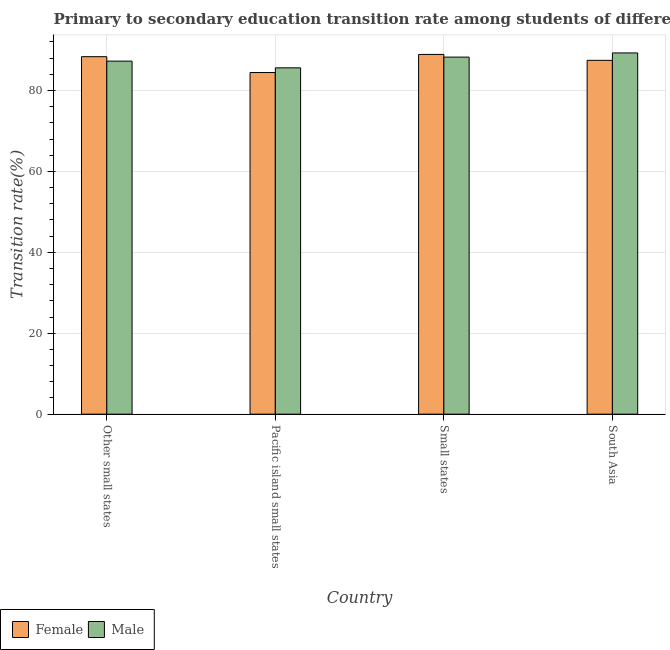How many different coloured bars are there?
Your answer should be very brief. 2. Are the number of bars per tick equal to the number of legend labels?
Keep it short and to the point. Yes. How many bars are there on the 1st tick from the left?
Provide a short and direct response. 2. How many bars are there on the 4th tick from the right?
Give a very brief answer. 2. What is the label of the 3rd group of bars from the left?
Keep it short and to the point. Small states. What is the transition rate among female students in South Asia?
Offer a terse response. 87.46. Across all countries, what is the maximum transition rate among male students?
Your response must be concise. 89.29. Across all countries, what is the minimum transition rate among female students?
Ensure brevity in your answer.  84.44. In which country was the transition rate among male students minimum?
Your answer should be very brief. Pacific island small states. What is the total transition rate among male students in the graph?
Give a very brief answer. 350.4. What is the difference between the transition rate among male students in Other small states and that in Small states?
Provide a short and direct response. -1. What is the difference between the transition rate among male students in Small states and the transition rate among female students in Other small states?
Offer a terse response. -0.11. What is the average transition rate among male students per country?
Your answer should be compact. 87.6. What is the difference between the transition rate among male students and transition rate among female students in Other small states?
Make the answer very short. -1.1. What is the ratio of the transition rate among male students in Pacific island small states to that in Small states?
Your answer should be compact. 0.97. Is the transition rate among male students in Other small states less than that in Pacific island small states?
Ensure brevity in your answer.  No. Is the difference between the transition rate among female students in Pacific island small states and Small states greater than the difference between the transition rate among male students in Pacific island small states and Small states?
Give a very brief answer. No. What is the difference between the highest and the second highest transition rate among female students?
Ensure brevity in your answer.  0.55. What is the difference between the highest and the lowest transition rate among female students?
Ensure brevity in your answer.  4.47. What does the 1st bar from the left in Other small states represents?
Keep it short and to the point. Female. Are all the bars in the graph horizontal?
Your response must be concise. No. How many countries are there in the graph?
Ensure brevity in your answer.  4. Are the values on the major ticks of Y-axis written in scientific E-notation?
Your answer should be compact. No. Does the graph contain grids?
Offer a very short reply. Yes. How many legend labels are there?
Offer a terse response. 2. What is the title of the graph?
Offer a terse response. Primary to secondary education transition rate among students of different countries. Does "Public funds" appear as one of the legend labels in the graph?
Ensure brevity in your answer.  No. What is the label or title of the X-axis?
Provide a succinct answer. Country. What is the label or title of the Y-axis?
Offer a very short reply. Transition rate(%). What is the Transition rate(%) in Female in Other small states?
Your response must be concise. 88.36. What is the Transition rate(%) in Male in Other small states?
Give a very brief answer. 87.26. What is the Transition rate(%) of Female in Pacific island small states?
Your answer should be compact. 84.44. What is the Transition rate(%) in Male in Pacific island small states?
Offer a very short reply. 85.6. What is the Transition rate(%) in Female in Small states?
Keep it short and to the point. 88.91. What is the Transition rate(%) in Male in Small states?
Offer a very short reply. 88.25. What is the Transition rate(%) in Female in South Asia?
Offer a very short reply. 87.46. What is the Transition rate(%) of Male in South Asia?
Your answer should be compact. 89.29. Across all countries, what is the maximum Transition rate(%) in Female?
Offer a terse response. 88.91. Across all countries, what is the maximum Transition rate(%) in Male?
Offer a very short reply. 89.29. Across all countries, what is the minimum Transition rate(%) of Female?
Make the answer very short. 84.44. Across all countries, what is the minimum Transition rate(%) in Male?
Your answer should be very brief. 85.6. What is the total Transition rate(%) of Female in the graph?
Provide a succinct answer. 349.18. What is the total Transition rate(%) in Male in the graph?
Offer a terse response. 350.4. What is the difference between the Transition rate(%) in Female in Other small states and that in Pacific island small states?
Provide a short and direct response. 3.92. What is the difference between the Transition rate(%) in Male in Other small states and that in Pacific island small states?
Give a very brief answer. 1.66. What is the difference between the Transition rate(%) in Female in Other small states and that in Small states?
Your response must be concise. -0.55. What is the difference between the Transition rate(%) in Male in Other small states and that in Small states?
Ensure brevity in your answer.  -1. What is the difference between the Transition rate(%) of Female in Other small states and that in South Asia?
Your answer should be compact. 0.9. What is the difference between the Transition rate(%) in Male in Other small states and that in South Asia?
Give a very brief answer. -2.03. What is the difference between the Transition rate(%) of Female in Pacific island small states and that in Small states?
Make the answer very short. -4.47. What is the difference between the Transition rate(%) of Male in Pacific island small states and that in Small states?
Provide a short and direct response. -2.65. What is the difference between the Transition rate(%) of Female in Pacific island small states and that in South Asia?
Your answer should be very brief. -3.01. What is the difference between the Transition rate(%) in Male in Pacific island small states and that in South Asia?
Keep it short and to the point. -3.68. What is the difference between the Transition rate(%) in Female in Small states and that in South Asia?
Your answer should be compact. 1.46. What is the difference between the Transition rate(%) of Male in Small states and that in South Asia?
Your response must be concise. -1.03. What is the difference between the Transition rate(%) in Female in Other small states and the Transition rate(%) in Male in Pacific island small states?
Offer a very short reply. 2.76. What is the difference between the Transition rate(%) of Female in Other small states and the Transition rate(%) of Male in Small states?
Provide a short and direct response. 0.11. What is the difference between the Transition rate(%) of Female in Other small states and the Transition rate(%) of Male in South Asia?
Make the answer very short. -0.92. What is the difference between the Transition rate(%) of Female in Pacific island small states and the Transition rate(%) of Male in Small states?
Offer a terse response. -3.81. What is the difference between the Transition rate(%) in Female in Pacific island small states and the Transition rate(%) in Male in South Asia?
Give a very brief answer. -4.84. What is the difference between the Transition rate(%) of Female in Small states and the Transition rate(%) of Male in South Asia?
Your response must be concise. -0.37. What is the average Transition rate(%) of Female per country?
Make the answer very short. 87.29. What is the average Transition rate(%) of Male per country?
Your answer should be very brief. 87.6. What is the difference between the Transition rate(%) in Female and Transition rate(%) in Male in Other small states?
Provide a short and direct response. 1.1. What is the difference between the Transition rate(%) in Female and Transition rate(%) in Male in Pacific island small states?
Ensure brevity in your answer.  -1.16. What is the difference between the Transition rate(%) in Female and Transition rate(%) in Male in Small states?
Offer a very short reply. 0.66. What is the difference between the Transition rate(%) of Female and Transition rate(%) of Male in South Asia?
Keep it short and to the point. -1.83. What is the ratio of the Transition rate(%) of Female in Other small states to that in Pacific island small states?
Offer a very short reply. 1.05. What is the ratio of the Transition rate(%) of Male in Other small states to that in Pacific island small states?
Your answer should be compact. 1.02. What is the ratio of the Transition rate(%) in Male in Other small states to that in Small states?
Provide a succinct answer. 0.99. What is the ratio of the Transition rate(%) in Female in Other small states to that in South Asia?
Give a very brief answer. 1.01. What is the ratio of the Transition rate(%) in Male in Other small states to that in South Asia?
Keep it short and to the point. 0.98. What is the ratio of the Transition rate(%) in Female in Pacific island small states to that in Small states?
Ensure brevity in your answer.  0.95. What is the ratio of the Transition rate(%) of Female in Pacific island small states to that in South Asia?
Provide a succinct answer. 0.97. What is the ratio of the Transition rate(%) in Male in Pacific island small states to that in South Asia?
Offer a terse response. 0.96. What is the ratio of the Transition rate(%) of Female in Small states to that in South Asia?
Provide a succinct answer. 1.02. What is the ratio of the Transition rate(%) of Male in Small states to that in South Asia?
Your response must be concise. 0.99. What is the difference between the highest and the second highest Transition rate(%) in Female?
Your answer should be compact. 0.55. What is the difference between the highest and the second highest Transition rate(%) in Male?
Keep it short and to the point. 1.03. What is the difference between the highest and the lowest Transition rate(%) of Female?
Provide a succinct answer. 4.47. What is the difference between the highest and the lowest Transition rate(%) in Male?
Provide a short and direct response. 3.68. 